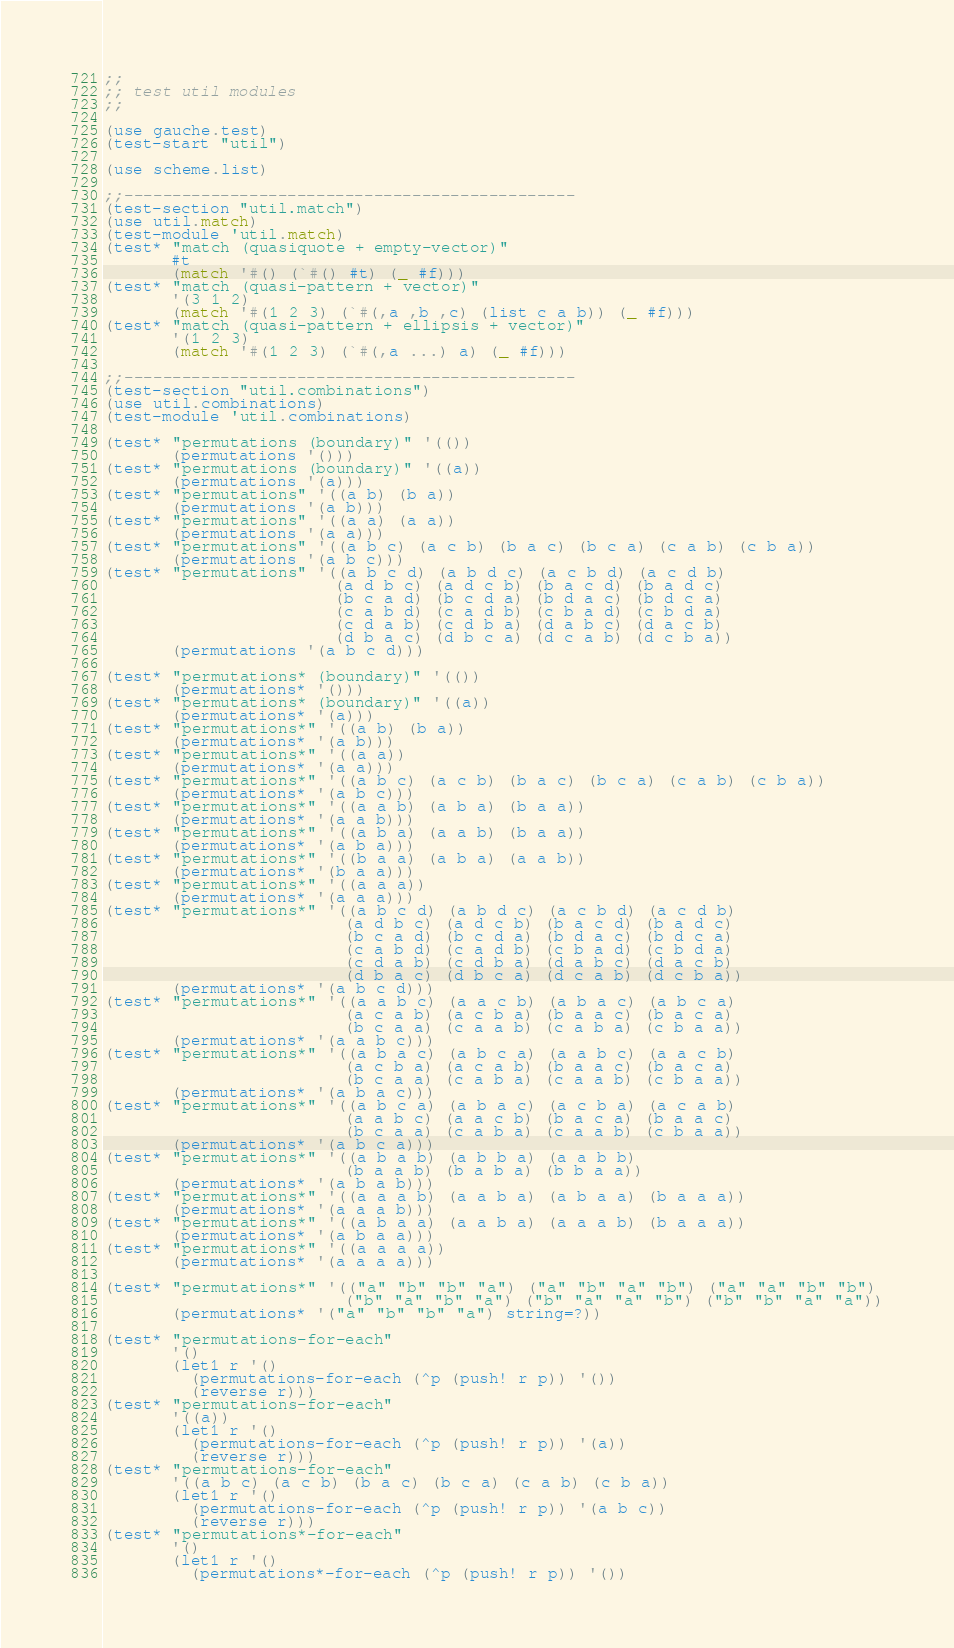Convert code to text. <code><loc_0><loc_0><loc_500><loc_500><_Scheme_>;;
;; test util modules
;;

(use gauche.test)
(test-start "util")

(use scheme.list)

;;-----------------------------------------------
(test-section "util.match")
(use util.match)
(test-module 'util.match)
(test* "match (quasiquote + empty-vector)"
       #t
       (match '#() (`#() #t) (_ #f)))
(test* "match (quasi-pattern + vector)"
       '(3 1 2)
       (match '#(1 2 3) (`#(,a ,b ,c) (list c a b)) (_ #f)))
(test* "match (quasi-pattern + ellipsis + vector)"
       '(1 2 3)
       (match '#(1 2 3) (`#(,a ...) a) (_ #f)))

;;-----------------------------------------------
(test-section "util.combinations")
(use util.combinations)
(test-module 'util.combinations)

(test* "permutations (boundary)" '(())
       (permutations '()))
(test* "permutations (boundary)" '((a))
       (permutations '(a)))
(test* "permutations" '((a b) (b a))
       (permutations '(a b)))
(test* "permutations" '((a a) (a a))
       (permutations '(a a)))
(test* "permutations" '((a b c) (a c b) (b a c) (b c a) (c a b) (c b a))
       (permutations '(a b c)))
(test* "permutations" '((a b c d) (a b d c) (a c b d) (a c d b)
                        (a d b c) (a d c b) (b a c d) (b a d c)
                        (b c a d) (b c d a) (b d a c) (b d c a)
                        (c a b d) (c a d b) (c b a d) (c b d a)
                        (c d a b) (c d b a) (d a b c) (d a c b)
                        (d b a c) (d b c a) (d c a b) (d c b a))
       (permutations '(a b c d)))

(test* "permutations* (boundary)" '(())
       (permutations* '()))
(test* "permutations* (boundary)" '((a))
       (permutations* '(a)))
(test* "permutations*" '((a b) (b a))
       (permutations* '(a b)))
(test* "permutations*" '((a a))
       (permutations* '(a a)))
(test* "permutations*" '((a b c) (a c b) (b a c) (b c a) (c a b) (c b a))
       (permutations* '(a b c)))
(test* "permutations*" '((a a b) (a b a) (b a a))
       (permutations* '(a a b)))
(test* "permutations*" '((a b a) (a a b) (b a a))
       (permutations* '(a b a)))
(test* "permutations*" '((b a a) (a b a) (a a b))
       (permutations* '(b a a)))
(test* "permutations*" '((a a a))
       (permutations* '(a a a)))
(test* "permutations*" '((a b c d) (a b d c) (a c b d) (a c d b)
                         (a d b c) (a d c b) (b a c d) (b a d c)
                         (b c a d) (b c d a) (b d a c) (b d c a)
                         (c a b d) (c a d b) (c b a d) (c b d a)
                         (c d a b) (c d b a) (d a b c) (d a c b)
                         (d b a c) (d b c a) (d c a b) (d c b a))
       (permutations* '(a b c d)))
(test* "permutations*" '((a a b c) (a a c b) (a b a c) (a b c a)
                         (a c a b) (a c b a) (b a a c) (b a c a)
                         (b c a a) (c a a b) (c a b a) (c b a a))
       (permutations* '(a a b c)))
(test* "permutations*" '((a b a c) (a b c a) (a a b c) (a a c b)
                         (a c b a) (a c a b) (b a a c) (b a c a)
                         (b c a a) (c a b a) (c a a b) (c b a a))
       (permutations* '(a b a c)))
(test* "permutations*" '((a b c a) (a b a c) (a c b a) (a c a b)
                         (a a b c) (a a c b) (b a c a) (b a a c)
                         (b c a a) (c a b a) (c a a b) (c b a a))
       (permutations* '(a b c a)))
(test* "permutations*" '((a b a b) (a b b a) (a a b b)
                         (b a a b) (b a b a) (b b a a))
       (permutations* '(a b a b)))
(test* "permutations*" '((a a a b) (a a b a) (a b a a) (b a a a))
       (permutations* '(a a a b)))
(test* "permutations*" '((a b a a) (a a b a) (a a a b) (b a a a))
       (permutations* '(a b a a)))
(test* "permutations*" '((a a a a))
       (permutations* '(a a a a)))

(test* "permutations*" '(("a" "b" "b" "a") ("a" "b" "a" "b") ("a" "a" "b" "b")
                         ("b" "a" "b" "a") ("b" "a" "a" "b") ("b" "b" "a" "a"))
       (permutations* '("a" "b" "b" "a") string=?))

(test* "permutations-for-each"
       '()
       (let1 r '()
         (permutations-for-each (^p (push! r p)) '())
         (reverse r)))
(test* "permutations-for-each"
       '((a))
       (let1 r '()
         (permutations-for-each (^p (push! r p)) '(a))
         (reverse r)))
(test* "permutations-for-each"
       '((a b c) (a c b) (b a c) (b c a) (c a b) (c b a))
       (let1 r '()
         (permutations-for-each (^p (push! r p)) '(a b c))
         (reverse r)))
(test* "permutations*-for-each"
       '()
       (let1 r '()
         (permutations*-for-each (^p (push! r p)) '())</code> 